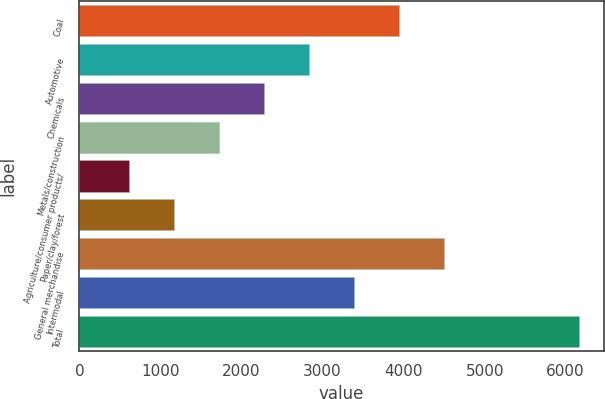Convert chart. <chart><loc_0><loc_0><loc_500><loc_500><bar_chart><fcel>Coal<fcel>Automotive<fcel>Chemicals<fcel>Metals/construction<fcel>Agriculture/consumer products/<fcel>Paper/clay/forest<fcel>General merchandise<fcel>Intermodal<fcel>Total<nl><fcel>3939<fcel>2829<fcel>2274<fcel>1719<fcel>609<fcel>1164<fcel>4494<fcel>3384<fcel>6159<nl></chart> 